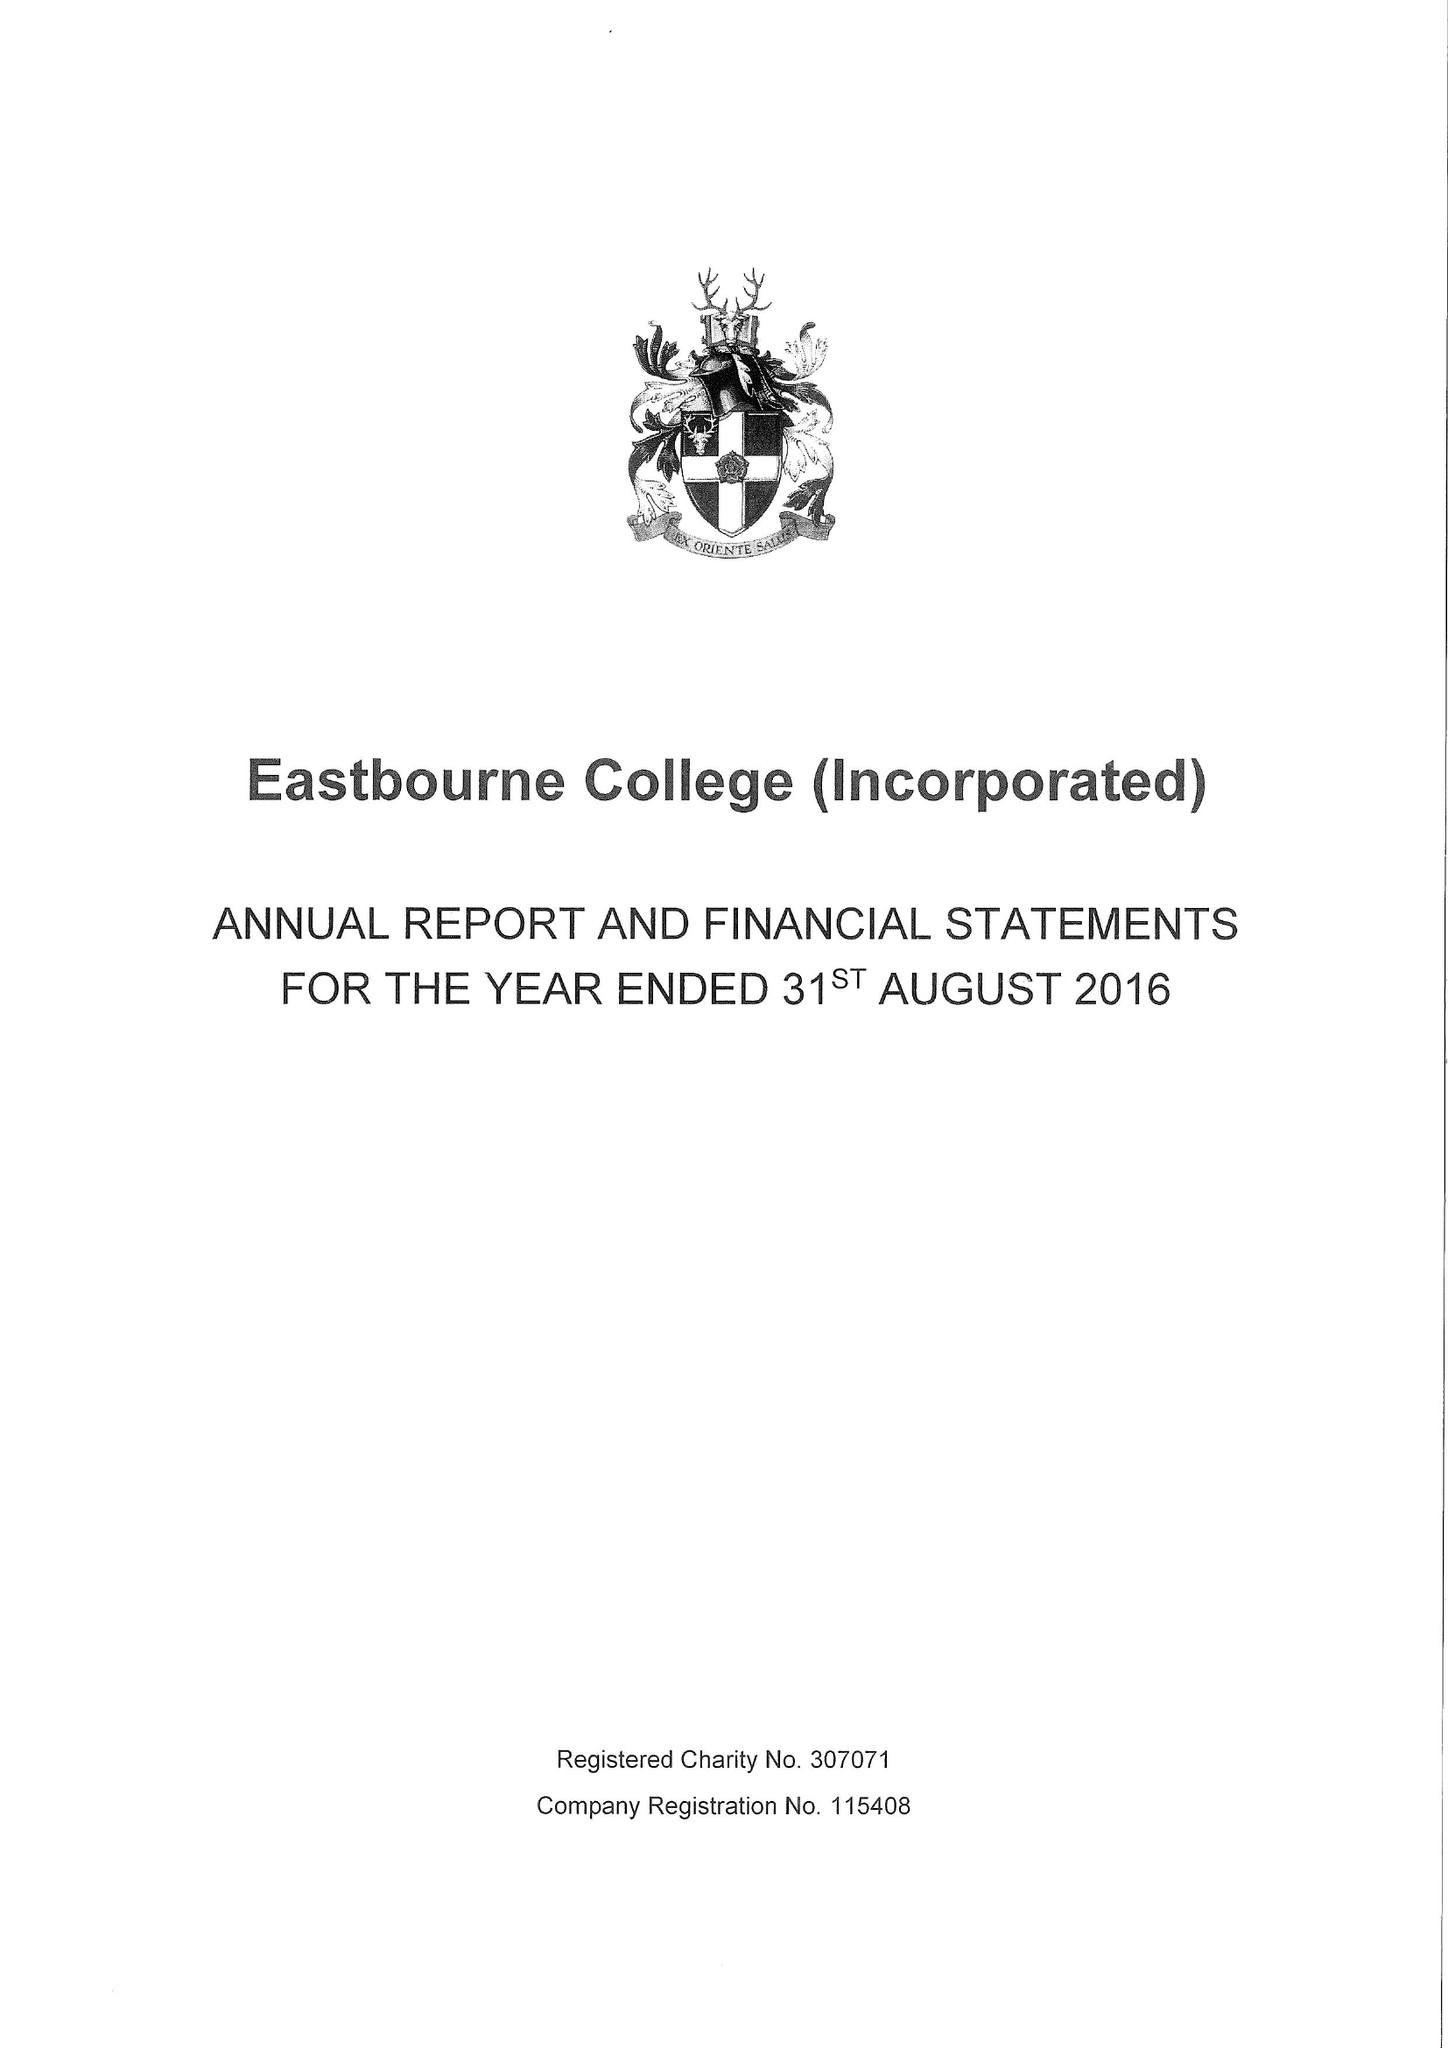What is the value for the spending_annually_in_british_pounds?
Answer the question using a single word or phrase. 19944000.00 